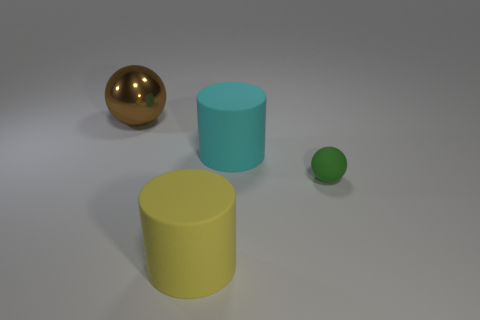Is there any other thing that is the same size as the matte sphere?
Your answer should be very brief. No. What number of things are either big metal balls or big blue matte objects?
Offer a terse response. 1. Is there anything else that has the same material as the large brown ball?
Offer a very short reply. No. Are there fewer large cylinders in front of the large cyan matte object than tiny purple matte cylinders?
Your answer should be very brief. No. Are there more shiny objects that are to the right of the tiny thing than metal things behind the yellow cylinder?
Give a very brief answer. No. Are there any other things of the same color as the small thing?
Offer a terse response. No. What is the large thing that is right of the big yellow cylinder made of?
Make the answer very short. Rubber. Is the size of the yellow cylinder the same as the green thing?
Offer a very short reply. No. How many other things are the same size as the brown thing?
Your answer should be very brief. 2. The large object in front of the cylinder that is behind the big cylinder in front of the cyan matte cylinder is what shape?
Give a very brief answer. Cylinder. 